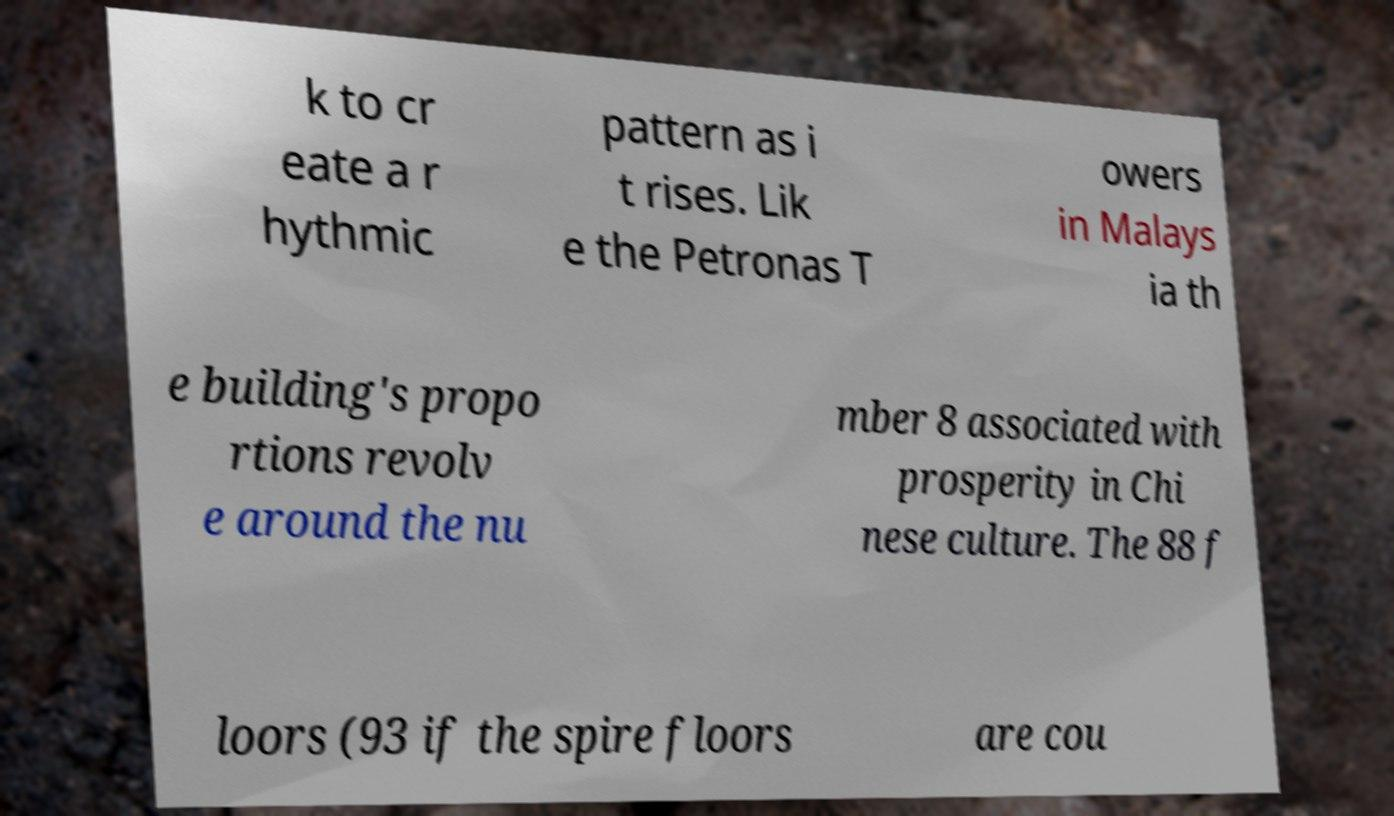There's text embedded in this image that I need extracted. Can you transcribe it verbatim? k to cr eate a r hythmic pattern as i t rises. Lik e the Petronas T owers in Malays ia th e building's propo rtions revolv e around the nu mber 8 associated with prosperity in Chi nese culture. The 88 f loors (93 if the spire floors are cou 